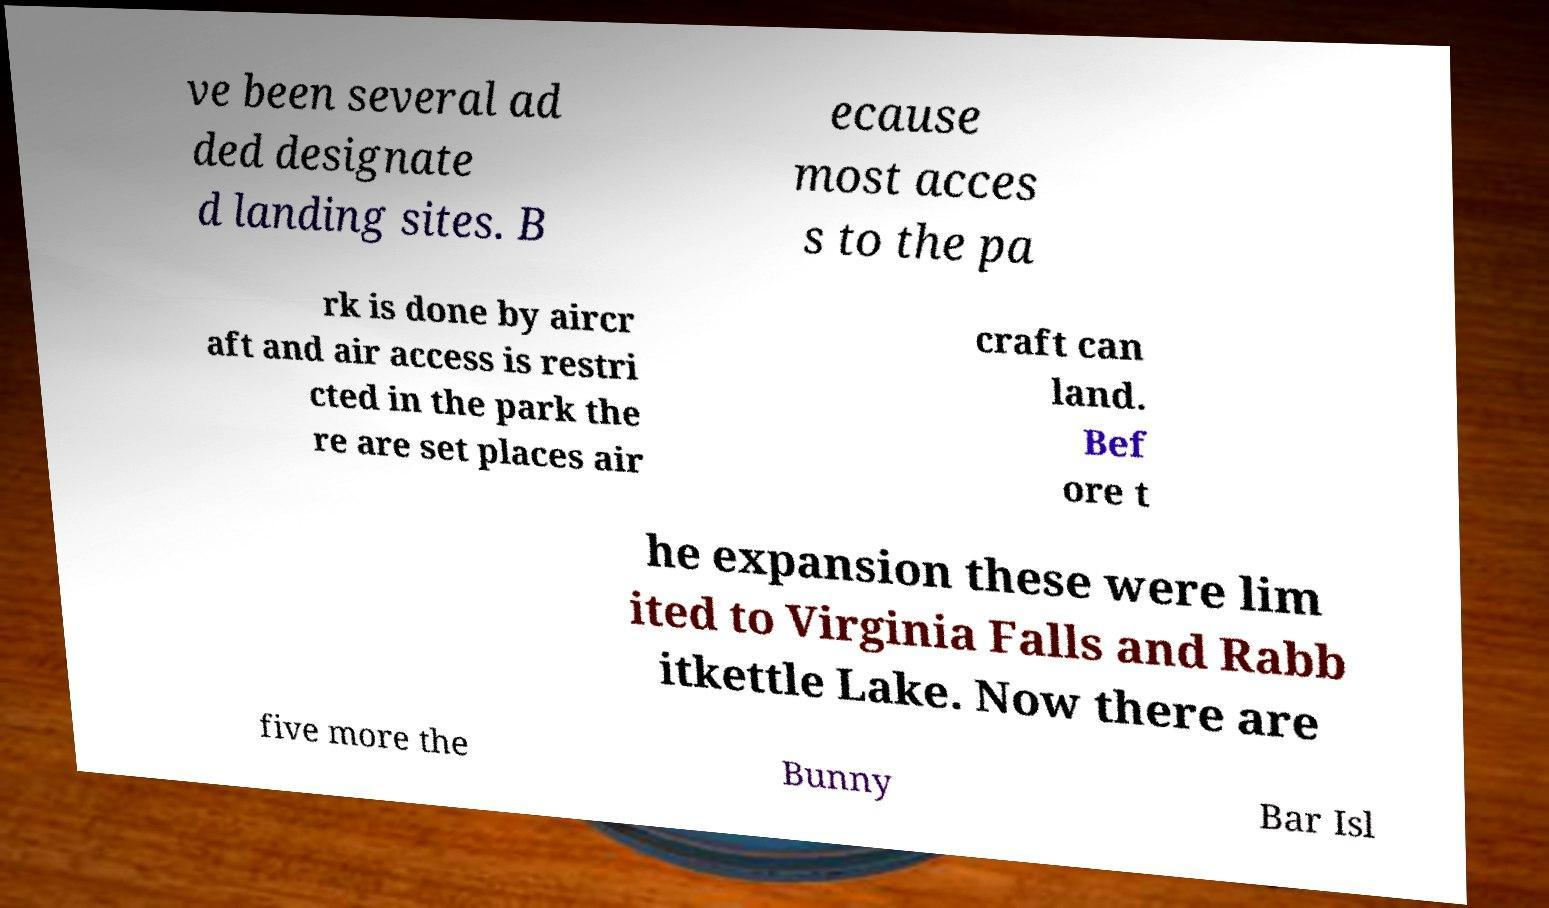Can you read and provide the text displayed in the image?This photo seems to have some interesting text. Can you extract and type it out for me? ve been several ad ded designate d landing sites. B ecause most acces s to the pa rk is done by aircr aft and air access is restri cted in the park the re are set places air craft can land. Bef ore t he expansion these were lim ited to Virginia Falls and Rabb itkettle Lake. Now there are five more the Bunny Bar Isl 